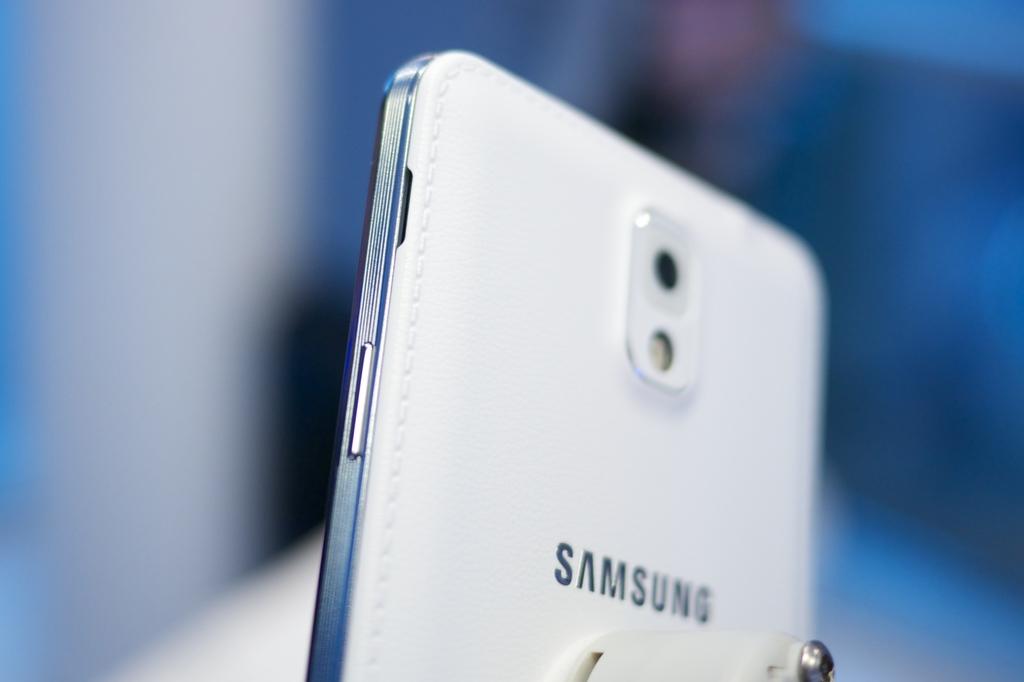What are the last 4 letters in the brand?
Provide a short and direct response. Sung. What brand of phone is this?
Keep it short and to the point. Samsung. 